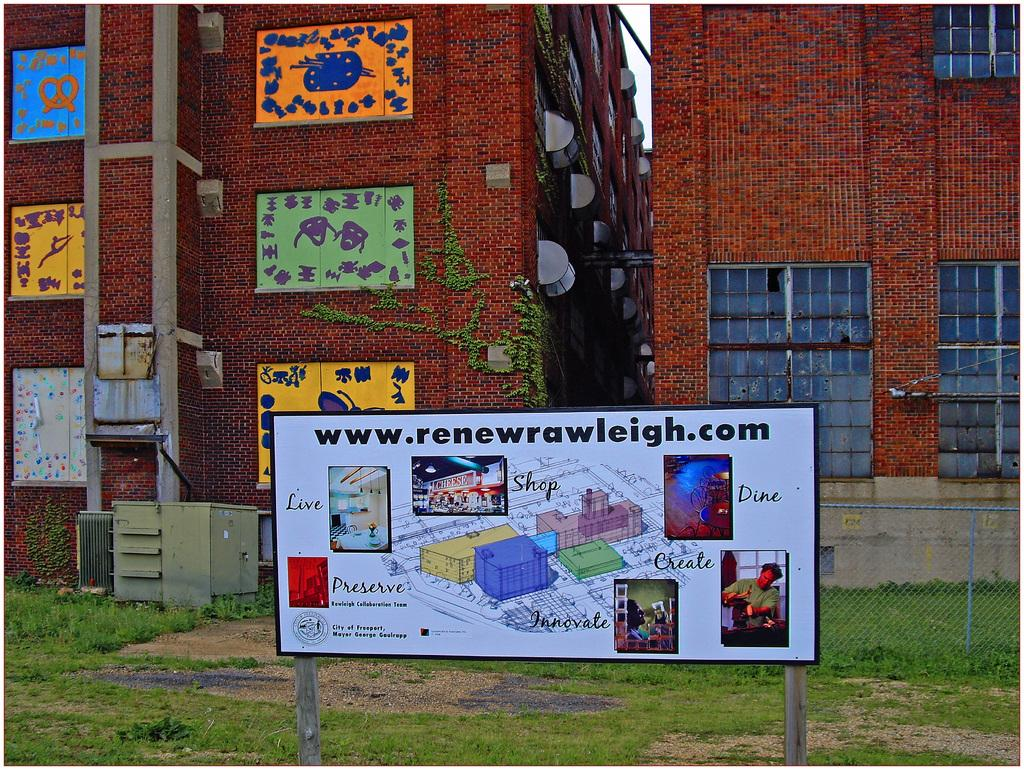<image>
Offer a succinct explanation of the picture presented. In front of a brick building with several colorful signs on it is a short, white billboard, that has the website www.renewrawleigh.com on the top. 